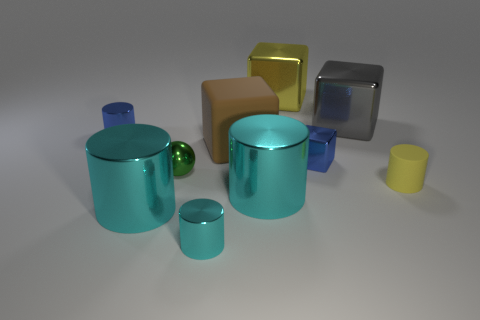Subtract all blue cubes. How many cubes are left? 3 Subtract all tiny metallic cylinders. How many cylinders are left? 3 Subtract 0 brown spheres. How many objects are left? 10 How many cyan cylinders must be subtracted to get 2 cyan cylinders? 1 Subtract all cubes. How many objects are left? 6 Subtract 1 balls. How many balls are left? 0 Subtract all blue cylinders. Subtract all green balls. How many cylinders are left? 4 Subtract all red cubes. How many cyan cylinders are left? 3 Subtract all tiny green cubes. Subtract all small objects. How many objects are left? 5 Add 4 big rubber objects. How many big rubber objects are left? 5 